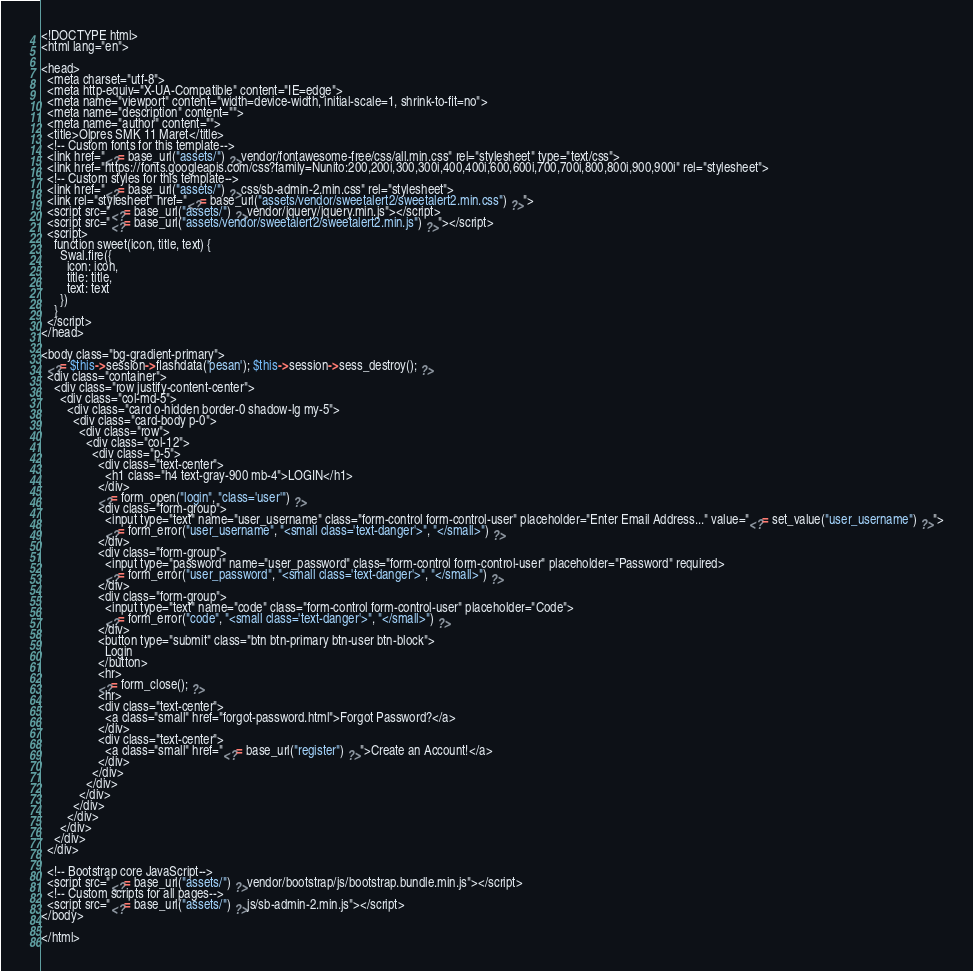<code> <loc_0><loc_0><loc_500><loc_500><_PHP_><!DOCTYPE html>
<html lang="en">

<head>
  <meta charset="utf-8">
  <meta http-equiv="X-UA-Compatible" content="IE=edge">
  <meta name="viewport" content="width=device-width, initial-scale=1, shrink-to-fit=no">
  <meta name="description" content="">
  <meta name="author" content="">
  <title>Olpres SMK 11 Maret</title>
  <!-- Custom fonts for this template-->
  <link href="<?= base_url("assets/") ?>vendor/fontawesome-free/css/all.min.css" rel="stylesheet" type="text/css">
  <link href="https://fonts.googleapis.com/css?family=Nunito:200,200i,300,300i,400,400i,600,600i,700,700i,800,800i,900,900i" rel="stylesheet">
  <!-- Custom styles for this template-->
  <link href="<?= base_url("assets/") ?>css/sb-admin-2.min.css" rel="stylesheet">
  <link rel="stylesheet" href="<?= base_url("assets/vendor/sweetalert2/sweetalert2.min.css") ?>">
  <script src="<?= base_url("assets/") ?>vendor/jquery/jquery.min.js"></script>
  <script src="<?= base_url("assets/vendor/sweetalert2/sweetalert2.min.js") ?>"></script>
  <script>
    function sweet(icon, title, text) {
      Swal.fire({
        icon: icon,
        title: title,
        text: text
      })
    }
  </script>
</head>

<body class="bg-gradient-primary">
  <?= $this->session->flashdata('pesan'); $this->session->sess_destroy(); ?>
  <div class="container">
    <div class="row justify-content-center">
      <div class="col-md-5">
        <div class="card o-hidden border-0 shadow-lg my-5">
          <div class="card-body p-0">
            <div class="row">
              <div class="col-12">
                <div class="p-5">
                  <div class="text-center">
                    <h1 class="h4 text-gray-900 mb-4">LOGIN</h1>
                  </div>
                  <?= form_open("login", "class='user'") ?>
                  <div class="form-group">
                    <input type="text" name="user_username" class="form-control form-control-user" placeholder="Enter Email Address..." value="<?= set_value("user_username") ?>">
                    <?= form_error("user_username", "<small class='text-danger'>", "</small>") ?>
                  </div>
                  <div class="form-group">
                    <input type="password" name="user_password" class="form-control form-control-user" placeholder="Password" required>
                    <?= form_error("user_password", "<small class='text-danger'>", "</small>") ?>
                  </div>
                  <div class="form-group">
                    <input type="text" name="code" class="form-control form-control-user" placeholder="Code">
                    <?= form_error("code", "<small class='text-danger'>", "</small>") ?>
                  </div>
                  <button type="submit" class="btn btn-primary btn-user btn-block">
                    Login
                  </button>
                  <hr>
                  <?= form_close(); ?>
                  <hr>
                  <div class="text-center">
                    <a class="small" href="forgot-password.html">Forgot Password?</a>
                  </div>
                  <div class="text-center">
                    <a class="small" href="<?= base_url("register") ?>">Create an Account!</a>
                  </div>
                </div>
              </div>
            </div>
          </div>
        </div>
      </div>
    </div>
  </div>

  <!-- Bootstrap core JavaScript-->
  <script src="<?= base_url("assets/") ?>vendor/bootstrap/js/bootstrap.bundle.min.js"></script>
  <!-- Custom scripts for all pages-->
  <script src="<?= base_url("assets/") ?>js/sb-admin-2.min.js"></script>
</body>

</html></code> 